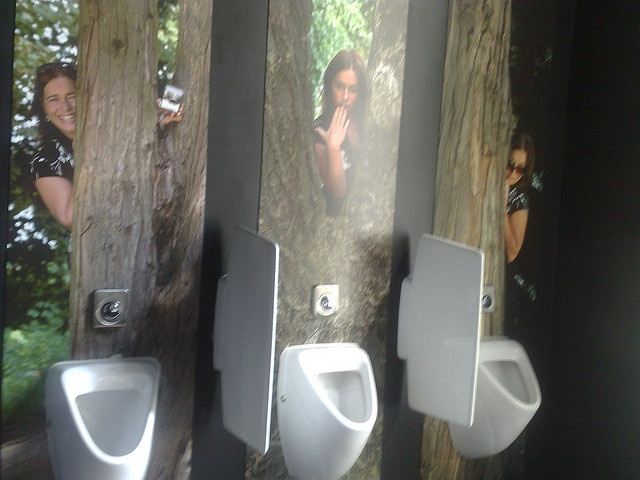Describe the objects in this image and their specific colors. I can see toilet in black, darkgray, gray, white, and lightgray tones, toilet in black, lightgray, and darkgray tones, toilet in black, darkgray, gray, and lightgray tones, people in black, darkgray, tan, and lightgray tones, and people in black, gray, and darkgray tones in this image. 